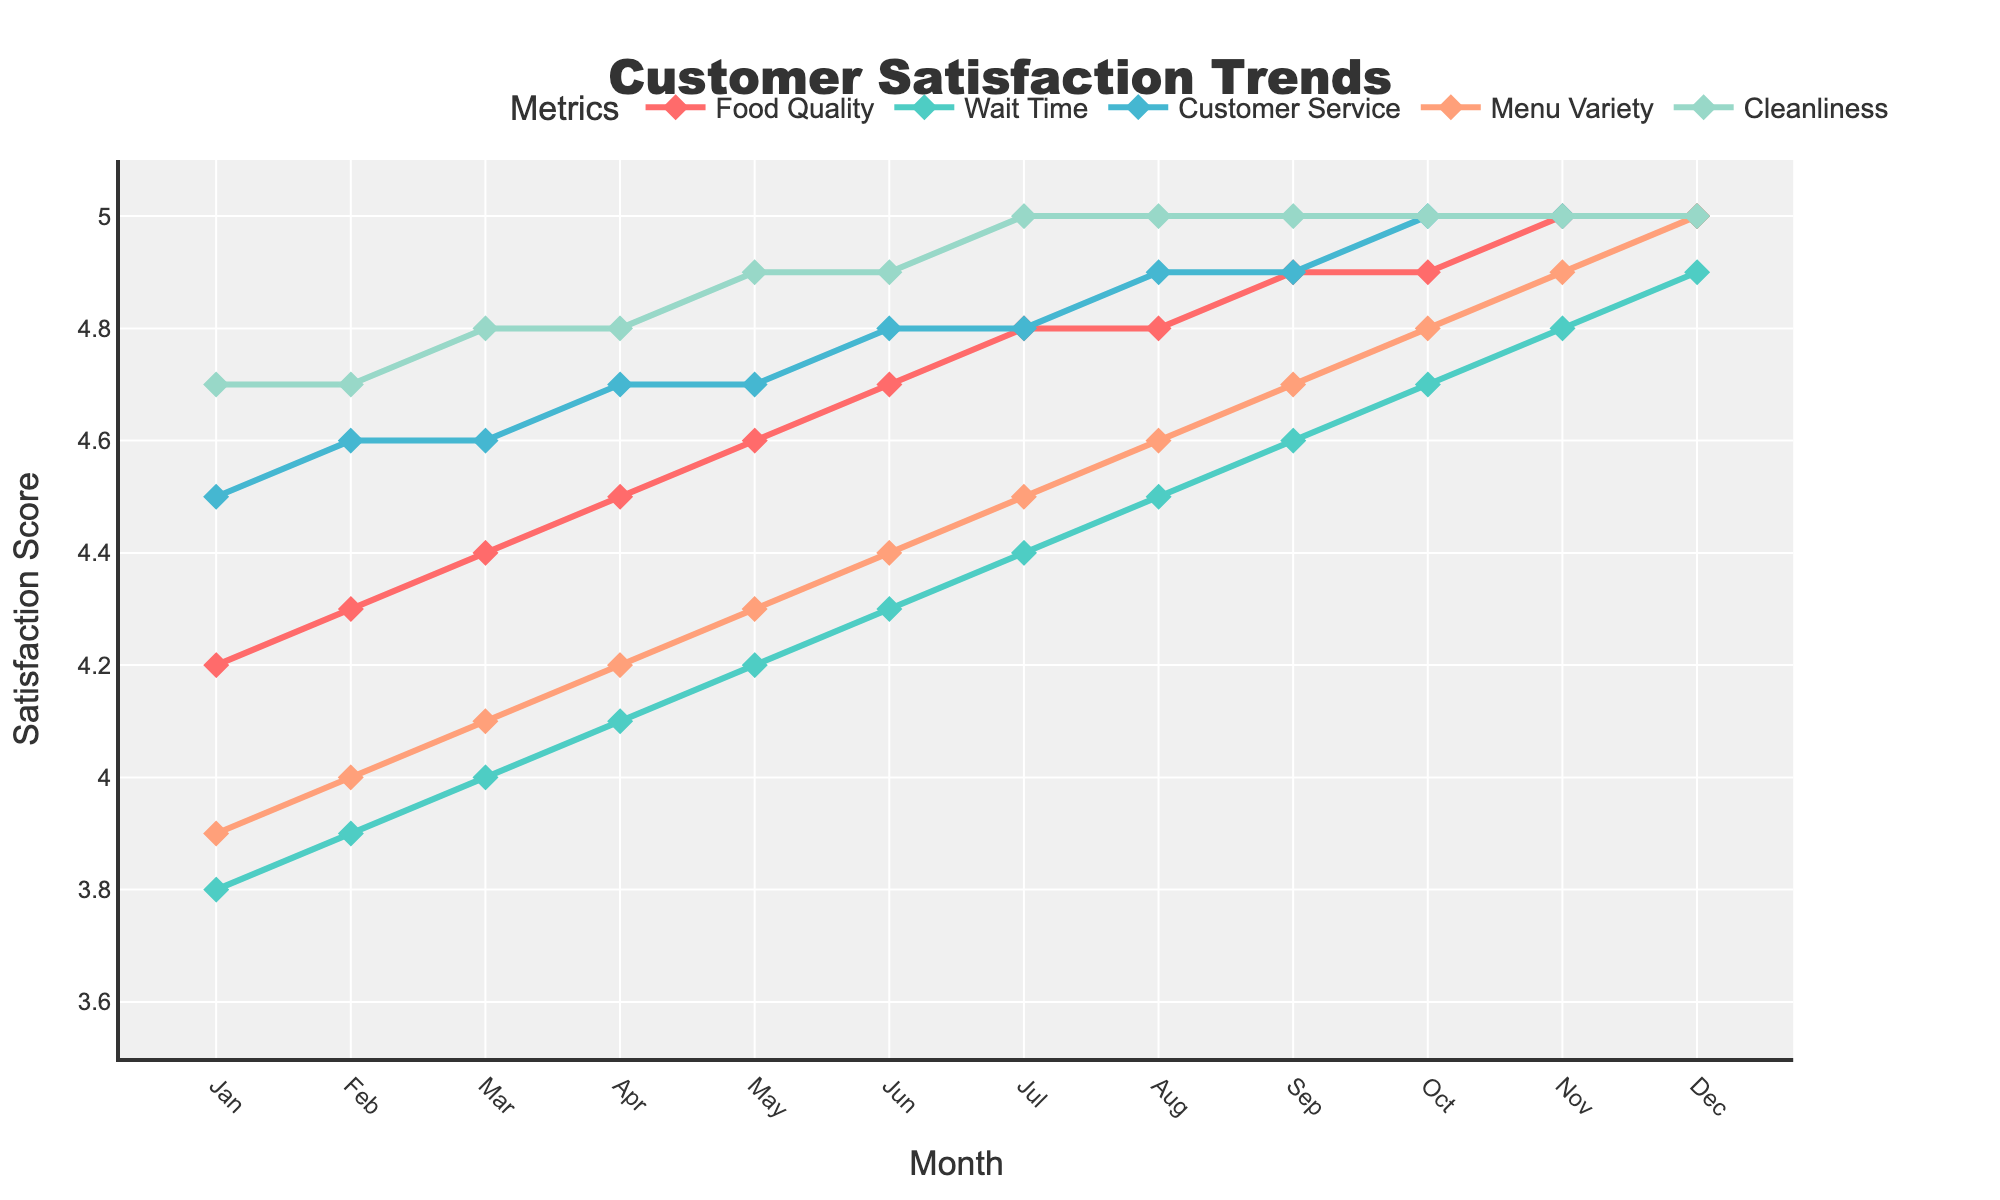What's the average Food Quality score for the first half of the year? Sum the scores from Jan to Jun (4.2 + 4.3 + 4.4 + 4.5 + 4.6 + 4.7) = 26.7. Divide by 6 (number of months) to get the average: 26.7 / 6 = 4.45
Answer: 4.45 Is Customer Service satisfaction higher in August or October? Compare the scores: August has a score of 4.9, and October has a score of 5.0. Since 5.0 is higher than 4.9, October has the higher score.
Answer: October Which month shows the highest satisfaction score for Cleanliness? Review the Cleanliness scores for each month. The highest score is 5.0, which is recorded in Jul, Aug, Sep, Oct, Nov, and Dec.
Answer: July to December Has the Wait Time satisfaction score consistently increased from January to December? Check the trend of Wait Time scores from January (3.8) to December (4.9). Since each score is higher than the preceding month, it shows a consistent increase.
Answer: Yes What’s the difference in Food Quality scores between January and December? Subtract January's Food Quality score from December's Food Quality score (5.0 - 4.2) = 0.8
Answer: 0.8 Which metric shows the most significant improvement over the year? Assess the difference between the January and December scores for each metric: Food Quality (5.0 - 4.2 = 0.8), Wait Time (4.9 - 3.8 = 1.1), Customer Service (5.0 - 4.5 = 0.5), Menu Variety (5.0 - 3.9 = 1.1), Cleanliness (5.0 - 4.7 = 0.3). The most significant improvement is 1.1, seen in Wait Time and Menu Variety.
Answer: Wait Time and Menu Variety In which months does every metric reach the maximum satisfaction score of 5.0? Check for the month where all metrics have a score of 5.0. This occurs from November and December.
Answer: November and December Between which two consecutive months is the most significant increase in Menu Variety observed? Calculate the month-over-month difference for Menu Variety: Feb-Jan (4.0-3.9=0.1), Mar-Feb (4.1-4.0=0.1), Apr-Mar (4.2-4.1=0.1), May-Apr (4.3-4.2=0.1), Jun-May (4.4-4.3=0.1), Jul-Jun (4.5-4.4=0.1), Aug-Jul (4.6-4.5=0.1), Sep-Aug (4.7-4.6=0.1), Oct-Sep (4.8-4.7=0.1), Nov-Oct (4.9-4.8=0.1), Dec-Nov (5.0-4.9=0.1). All differences are 0.1, hence the increase is uniform each month.
Answer: All months 